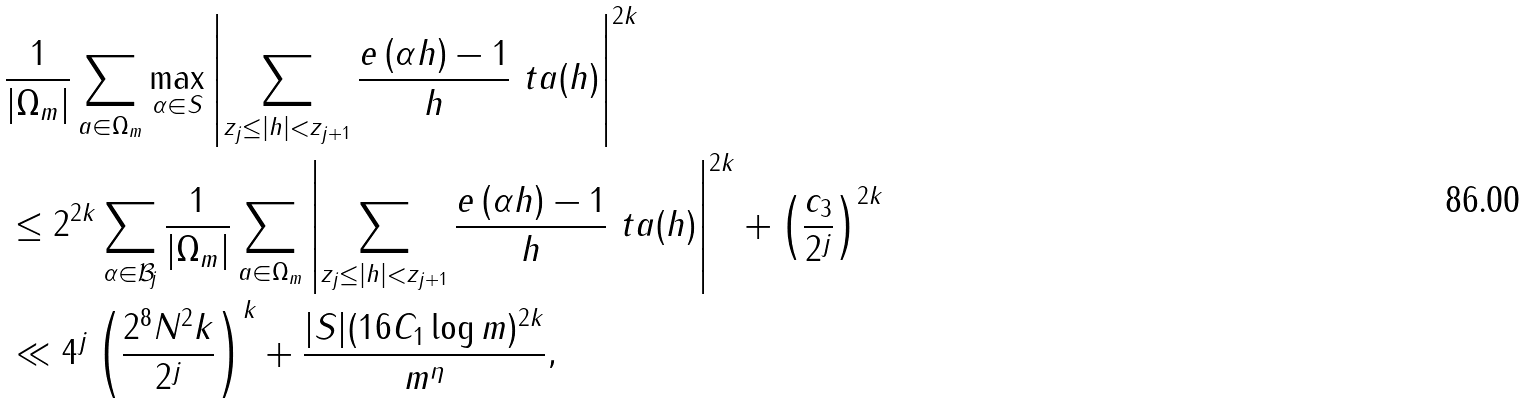Convert formula to latex. <formula><loc_0><loc_0><loc_500><loc_500>& \frac { 1 } { | \Omega _ { m } | } \sum _ { a \in \Omega _ { m } } \max _ { \alpha \in S } \left | \sum _ { z _ { j } \leq | h | < z _ { j + 1 } } \frac { e \left ( \alpha h \right ) - 1 } { h } \ t a ( h ) \right | ^ { 2 k } \\ & \leq 2 ^ { 2 k } \sum _ { \alpha \in \mathcal { B } _ { j } } \frac { 1 } { | \Omega _ { m } | } \sum _ { a \in \Omega _ { m } } \left | \sum _ { z _ { j } \leq | h | < z _ { j + 1 } } \frac { e \left ( \alpha h \right ) - 1 } { h } \ t a ( h ) \right | ^ { 2 k } + \left ( \frac { c _ { 3 } } { 2 ^ { j } } \right ) ^ { 2 k } \\ & \ll 4 ^ { j } \left ( \frac { 2 ^ { 8 } N ^ { 2 } k } { 2 ^ { j } } \right ) ^ { k } + \frac { | S | ( 1 6 C _ { 1 } \log m ) ^ { 2 k } } { m ^ { \eta } } ,</formula> 